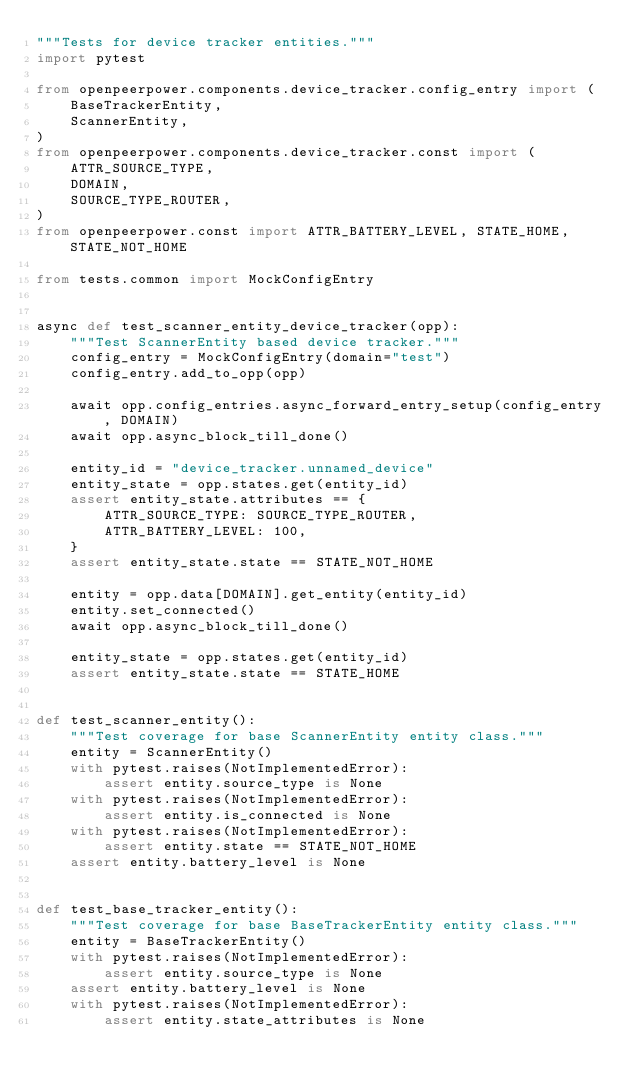Convert code to text. <code><loc_0><loc_0><loc_500><loc_500><_Python_>"""Tests for device tracker entities."""
import pytest

from openpeerpower.components.device_tracker.config_entry import (
    BaseTrackerEntity,
    ScannerEntity,
)
from openpeerpower.components.device_tracker.const import (
    ATTR_SOURCE_TYPE,
    DOMAIN,
    SOURCE_TYPE_ROUTER,
)
from openpeerpower.const import ATTR_BATTERY_LEVEL, STATE_HOME, STATE_NOT_HOME

from tests.common import MockConfigEntry


async def test_scanner_entity_device_tracker(opp):
    """Test ScannerEntity based device tracker."""
    config_entry = MockConfigEntry(domain="test")
    config_entry.add_to_opp(opp)

    await opp.config_entries.async_forward_entry_setup(config_entry, DOMAIN)
    await opp.async_block_till_done()

    entity_id = "device_tracker.unnamed_device"
    entity_state = opp.states.get(entity_id)
    assert entity_state.attributes == {
        ATTR_SOURCE_TYPE: SOURCE_TYPE_ROUTER,
        ATTR_BATTERY_LEVEL: 100,
    }
    assert entity_state.state == STATE_NOT_HOME

    entity = opp.data[DOMAIN].get_entity(entity_id)
    entity.set_connected()
    await opp.async_block_till_done()

    entity_state = opp.states.get(entity_id)
    assert entity_state.state == STATE_HOME


def test_scanner_entity():
    """Test coverage for base ScannerEntity entity class."""
    entity = ScannerEntity()
    with pytest.raises(NotImplementedError):
        assert entity.source_type is None
    with pytest.raises(NotImplementedError):
        assert entity.is_connected is None
    with pytest.raises(NotImplementedError):
        assert entity.state == STATE_NOT_HOME
    assert entity.battery_level is None


def test_base_tracker_entity():
    """Test coverage for base BaseTrackerEntity entity class."""
    entity = BaseTrackerEntity()
    with pytest.raises(NotImplementedError):
        assert entity.source_type is None
    assert entity.battery_level is None
    with pytest.raises(NotImplementedError):
        assert entity.state_attributes is None
</code> 